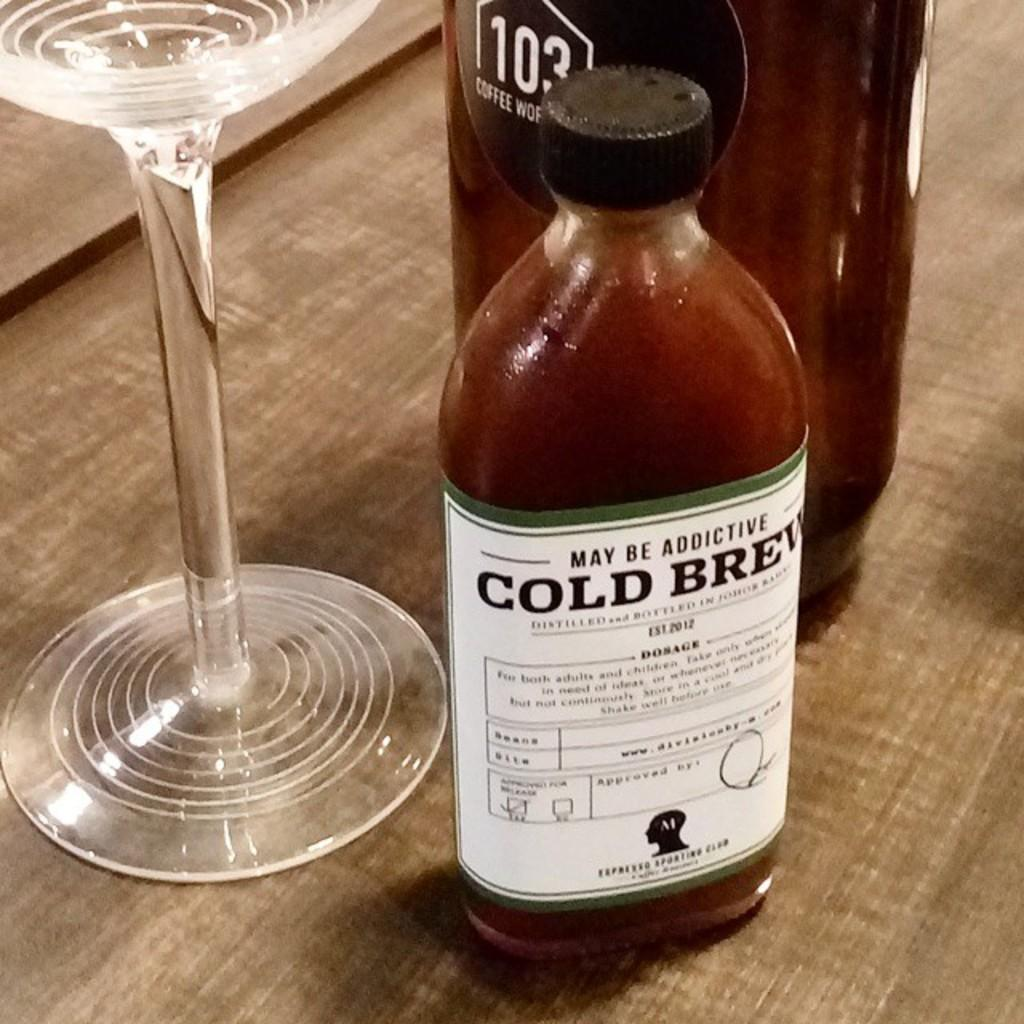What type of container is visible in the image? There is a glass in the image. How many bottles are present in the image? There are two bottles in the image. What is the surface that the glass and bottles are placed on? The glass and bottles are on a wooden surface. What type of underwear is being compared in the image? There is no underwear present in the image, and therefore no comparison can be made. 